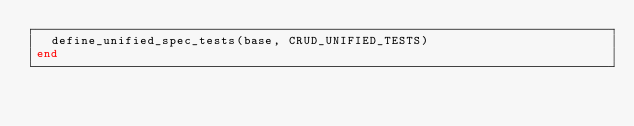<code> <loc_0><loc_0><loc_500><loc_500><_Ruby_>  define_unified_spec_tests(base, CRUD_UNIFIED_TESTS)
end
</code> 